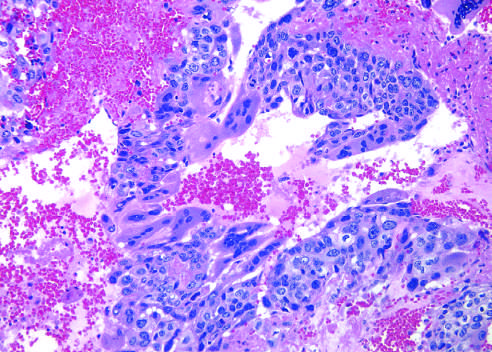what are prominent?
Answer the question using a single word or phrase. Hemorrhage and necrosis 